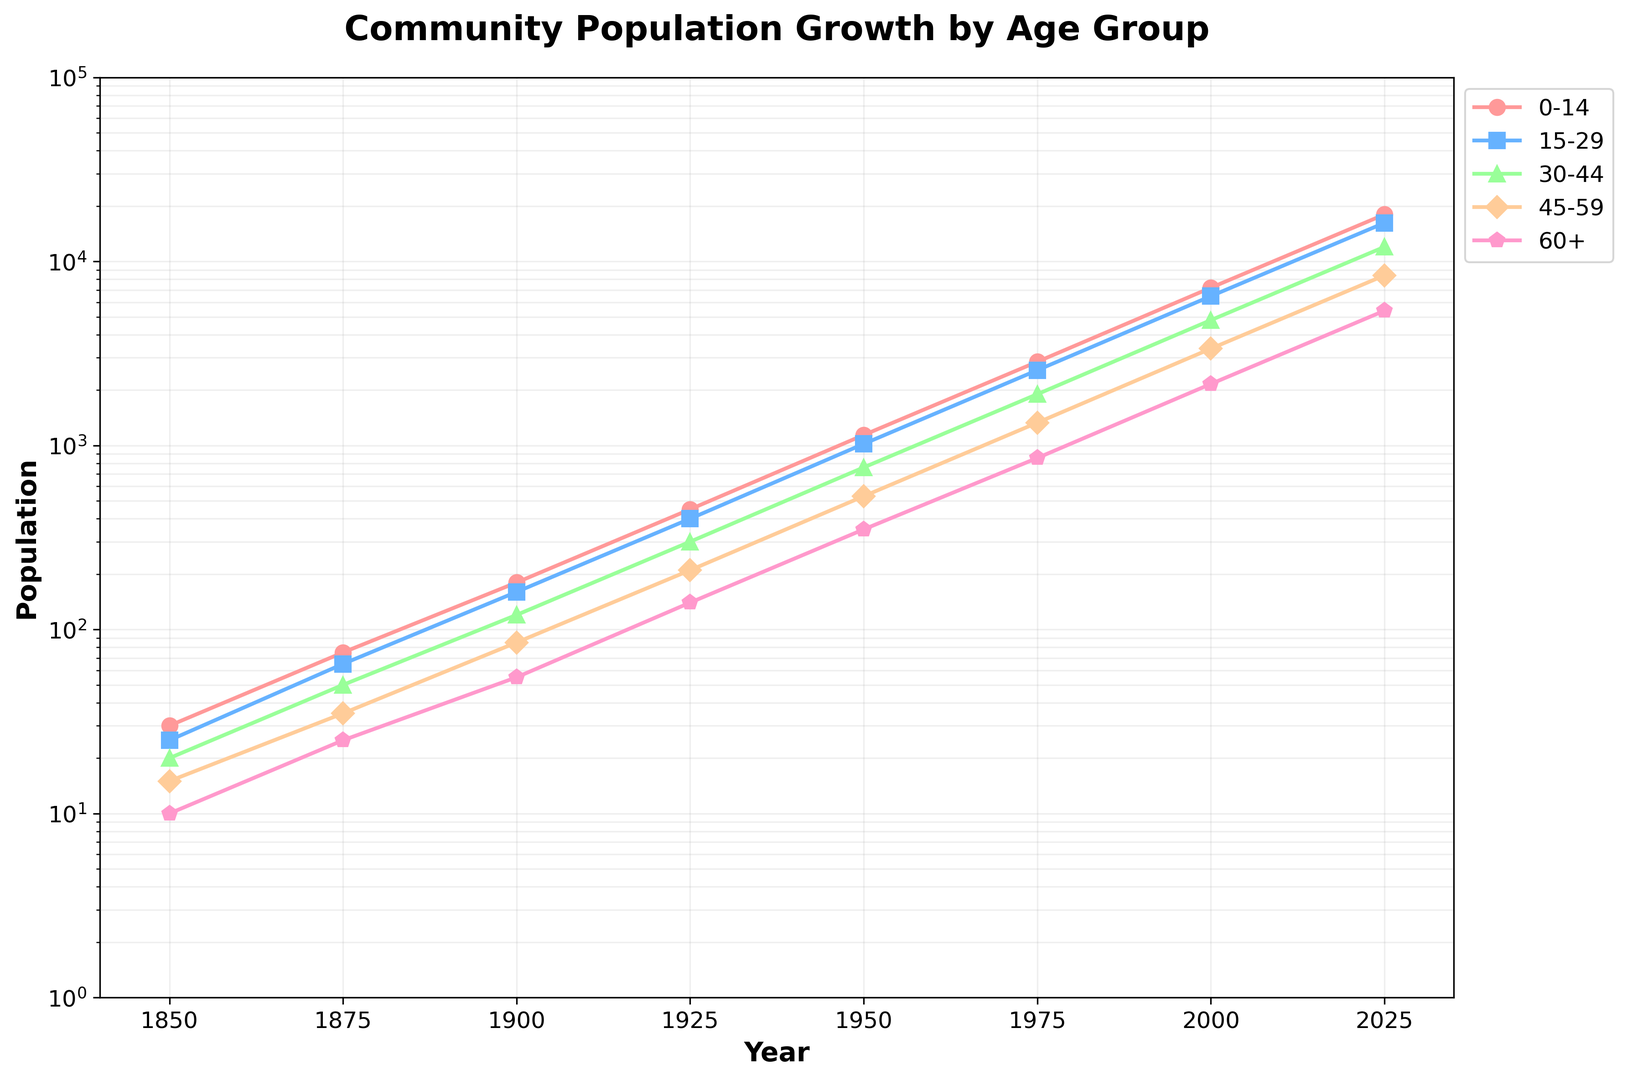What is the population of the 0-14 age group in the year 1950? To find this, locate the year 1950 on the x-axis and then check the value for the 0-14 age group (represented by red circles). The corresponding y-axis value is 1140.
Answer: 1140 Which age group had the highest population in the year 2000? Locate the year 2000 on the x-axis and compare the y-axis values for each age group. The 0-14 age group shows the highest value among the groups, represented as 7200.
Answer: 0-14 By how much did the total population increase from 1875 to 1900? Look at the total population values for 1875 and 1900, which are 250 and 600 respectively. Calculate the difference: 600 - 250 = 350.
Answer: 350 How does the population of the 30-44 age group in 2025 compare to that in 1975? Locate the populations of the 30-44 age group for 2025 and 1975 on the y-axis. For 1975, it is 1900, and for 2025, it is 12000. Since 12000 is larger than 1900, the population increased.
Answer: Increased What was the percentage increase in the total population from 1925 to 1950? The total population in 1925 is 1500, and in 1950 it is 3800. Calculate the percentage increase: ((3800 - 1500) / 1500) * 100 = 153.33%.
Answer: 153.33% In which decade did the 60+ age group see its first population exceeding 1000? Follow the 60+ age group line on the plot and identify the first point where the population value on the y-axis exceeds 1000. This occurs around the year 1950 but grows significantly in the 1970s. The population first exceeds 1000 in the 1975 data point.
Answer: 1970s 